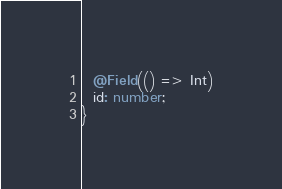Convert code to text. <code><loc_0><loc_0><loc_500><loc_500><_TypeScript_>  @Field(() => Int)
  id: number;
}
</code> 